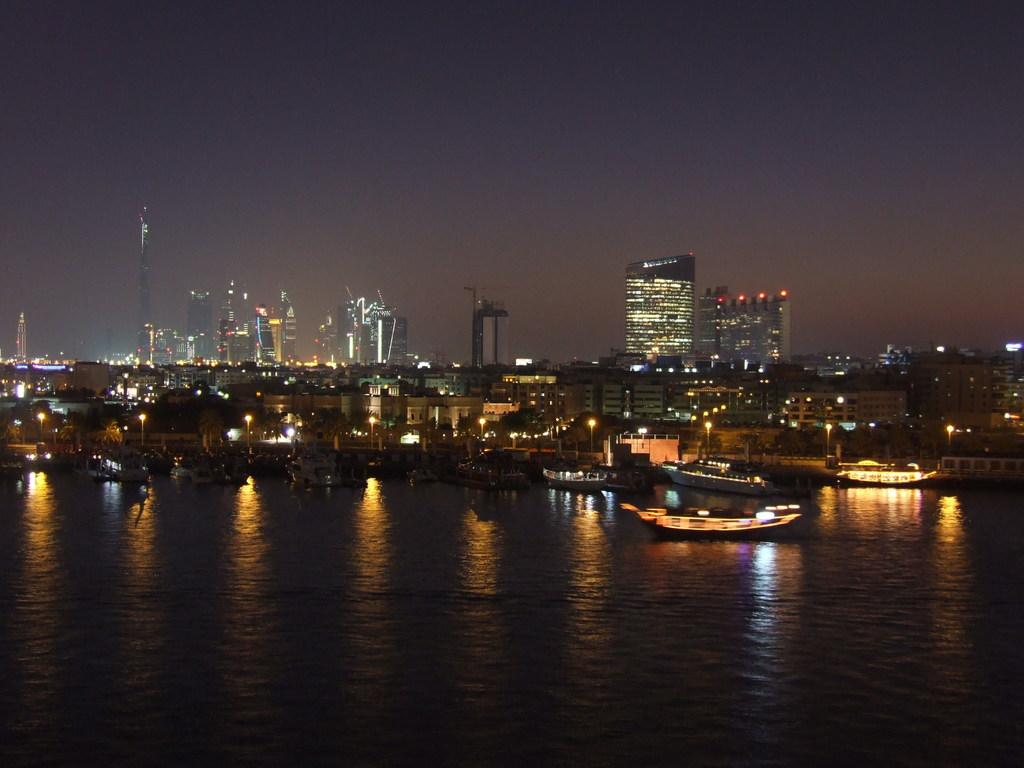What is in the foreground of the image? There is a water surface in the foreground of the image. What is on the water surface? There are boats on the water surface. What structures can be seen in the image? There are towers and buildings visible in the image. What shape is the juice container in the image? There is no juice container present in the image. How does the grip of the person holding the shape affect the image? There is no person holding a shape in the image. 